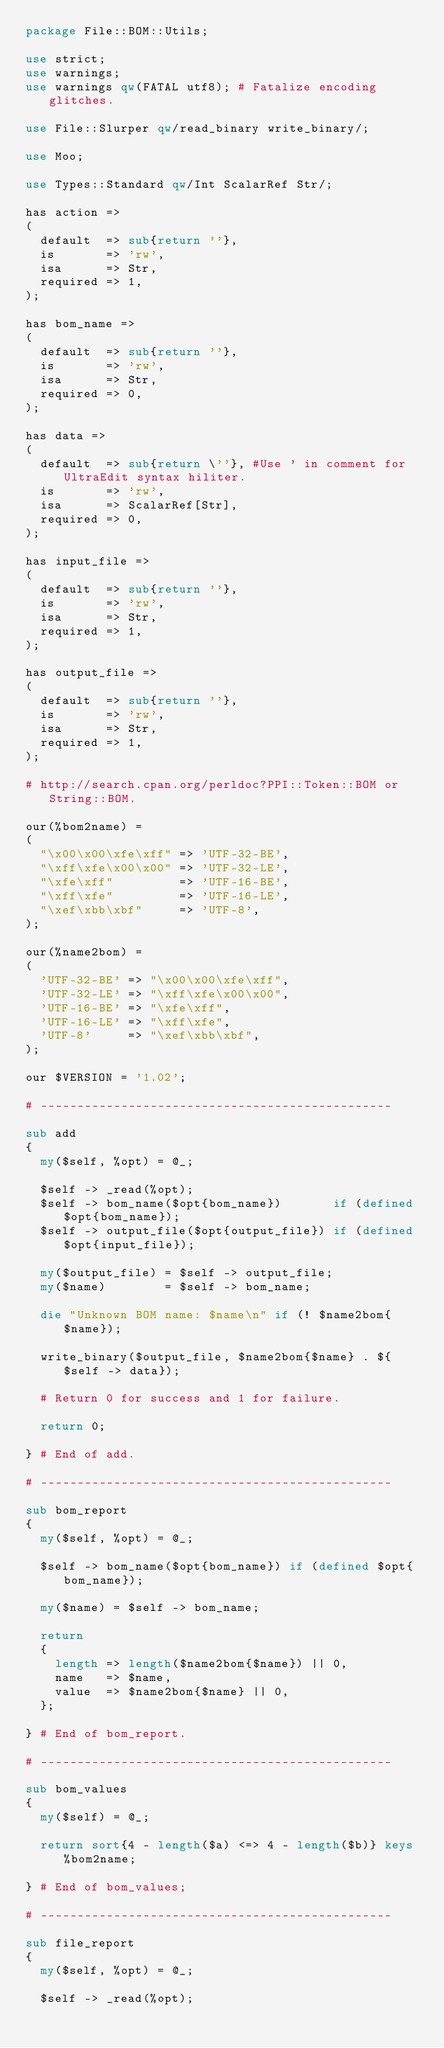<code> <loc_0><loc_0><loc_500><loc_500><_Perl_>package File::BOM::Utils;

use strict;
use warnings;
use warnings qw(FATAL utf8); # Fatalize encoding glitches.

use File::Slurper qw/read_binary write_binary/;

use Moo;

use Types::Standard qw/Int ScalarRef Str/;

has action =>
(
	default  => sub{return ''},
	is       => 'rw',
	isa      => Str,
	required => 1,
);

has bom_name =>
(
	default  => sub{return ''},
	is       => 'rw',
	isa      => Str,
	required => 0,
);

has data =>
(
	default  => sub{return \''}, #Use ' in comment for UltraEdit syntax hiliter.
	is       => 'rw',
	isa      => ScalarRef[Str],
	required => 0,
);

has input_file =>
(
	default  => sub{return ''},
	is       => 'rw',
	isa      => Str,
	required => 1,
);

has output_file =>
(
	default  => sub{return ''},
	is       => 'rw',
	isa      => Str,
	required => 1,
);

# http://search.cpan.org/perldoc?PPI::Token::BOM or String::BOM.

our(%bom2name) =
(
	"\x00\x00\xfe\xff" => 'UTF-32-BE',
	"\xff\xfe\x00\x00" => 'UTF-32-LE',
	"\xfe\xff"         => 'UTF-16-BE',
	"\xff\xfe"         => 'UTF-16-LE',
	"\xef\xbb\xbf"     => 'UTF-8',
);

our(%name2bom) =
(
	'UTF-32-BE' => "\x00\x00\xfe\xff",
	'UTF-32-LE' => "\xff\xfe\x00\x00",
	'UTF-16-BE' => "\xfe\xff",
	'UTF-16-LE' => "\xff\xfe",
	'UTF-8'     => "\xef\xbb\xbf",
);

our $VERSION = '1.02';

# ------------------------------------------------

sub add
{
	my($self, %opt) = @_;

	$self -> _read(%opt);
	$self -> bom_name($opt{bom_name})       if (defined $opt{bom_name});
	$self -> output_file($opt{output_file}) if (defined $opt{input_file});

	my($output_file) = $self -> output_file;
	my($name)        = $self -> bom_name;

	die "Unknown BOM name: $name\n" if (! $name2bom{$name});

	write_binary($output_file, $name2bom{$name} . ${$self -> data});

	# Return 0 for success and 1 for failure.

	return 0;

} # End of add.

# ------------------------------------------------

sub bom_report
{
	my($self, %opt) = @_;

	$self -> bom_name($opt{bom_name}) if (defined $opt{bom_name});

	my($name) = $self -> bom_name;

	return
	{
		length => length($name2bom{$name}) || 0,
		name   => $name,
		value  => $name2bom{$name} || 0,
	};

} # End of bom_report.

# ------------------------------------------------

sub bom_values
{
	my($self) = @_;

	return sort{4 - length($a) <=> 4 - length($b)} keys %bom2name;

} # End of bom_values;

# ------------------------------------------------

sub file_report
{
	my($self, %opt) = @_;

	$self -> _read(%opt);
</code> 